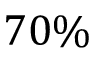<formula> <loc_0><loc_0><loc_500><loc_500>7 0 \%</formula> 